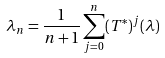Convert formula to latex. <formula><loc_0><loc_0><loc_500><loc_500>\lambda _ { n } = \frac { 1 } { n + 1 } \sum _ { j = 0 } ^ { n } ( T ^ { * } ) ^ { j } ( \lambda )</formula> 